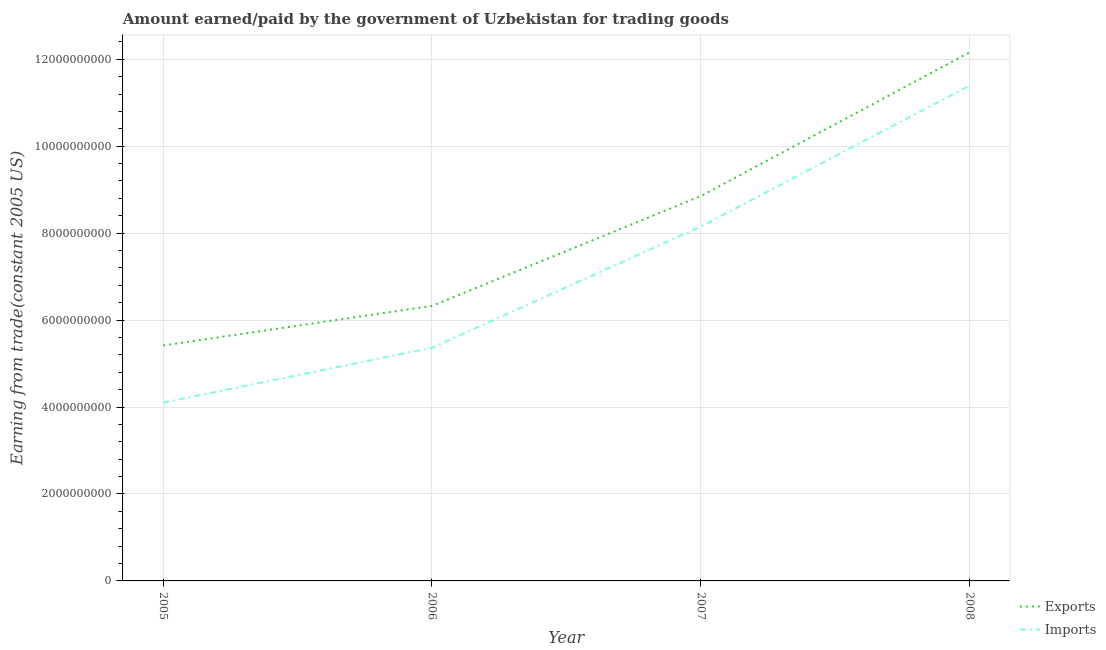Is the number of lines equal to the number of legend labels?
Offer a terse response. Yes. What is the amount paid for imports in 2005?
Offer a very short reply. 4.10e+09. Across all years, what is the maximum amount earned from exports?
Your response must be concise. 1.22e+1. Across all years, what is the minimum amount earned from exports?
Provide a short and direct response. 5.42e+09. What is the total amount earned from exports in the graph?
Give a very brief answer. 3.28e+1. What is the difference between the amount paid for imports in 2005 and that in 2006?
Your response must be concise. -1.26e+09. What is the difference between the amount earned from exports in 2006 and the amount paid for imports in 2005?
Offer a very short reply. 2.23e+09. What is the average amount earned from exports per year?
Ensure brevity in your answer.  8.19e+09. In the year 2008, what is the difference between the amount earned from exports and amount paid for imports?
Your answer should be very brief. 7.65e+08. What is the ratio of the amount earned from exports in 2005 to that in 2008?
Give a very brief answer. 0.45. Is the amount paid for imports in 2006 less than that in 2007?
Offer a very short reply. Yes. Is the difference between the amount paid for imports in 2006 and 2007 greater than the difference between the amount earned from exports in 2006 and 2007?
Your answer should be very brief. No. What is the difference between the highest and the second highest amount paid for imports?
Make the answer very short. 3.24e+09. What is the difference between the highest and the lowest amount paid for imports?
Provide a short and direct response. 7.29e+09. Is the sum of the amount earned from exports in 2007 and 2008 greater than the maximum amount paid for imports across all years?
Keep it short and to the point. Yes. Does the amount earned from exports monotonically increase over the years?
Keep it short and to the point. Yes. Is the amount paid for imports strictly greater than the amount earned from exports over the years?
Make the answer very short. No. How many years are there in the graph?
Provide a succinct answer. 4. Are the values on the major ticks of Y-axis written in scientific E-notation?
Provide a short and direct response. No. Does the graph contain any zero values?
Provide a short and direct response. No. Does the graph contain grids?
Your answer should be compact. Yes. How are the legend labels stacked?
Ensure brevity in your answer.  Vertical. What is the title of the graph?
Your answer should be very brief. Amount earned/paid by the government of Uzbekistan for trading goods. Does "Working capital" appear as one of the legend labels in the graph?
Keep it short and to the point. No. What is the label or title of the X-axis?
Make the answer very short. Year. What is the label or title of the Y-axis?
Make the answer very short. Earning from trade(constant 2005 US). What is the Earning from trade(constant 2005 US) in Exports in 2005?
Offer a terse response. 5.42e+09. What is the Earning from trade(constant 2005 US) in Imports in 2005?
Provide a short and direct response. 4.10e+09. What is the Earning from trade(constant 2005 US) of Exports in 2006?
Your answer should be very brief. 6.33e+09. What is the Earning from trade(constant 2005 US) of Imports in 2006?
Keep it short and to the point. 5.36e+09. What is the Earning from trade(constant 2005 US) of Exports in 2007?
Offer a terse response. 8.85e+09. What is the Earning from trade(constant 2005 US) in Imports in 2007?
Keep it short and to the point. 8.15e+09. What is the Earning from trade(constant 2005 US) in Exports in 2008?
Make the answer very short. 1.22e+1. What is the Earning from trade(constant 2005 US) of Imports in 2008?
Offer a terse response. 1.14e+1. Across all years, what is the maximum Earning from trade(constant 2005 US) of Exports?
Offer a terse response. 1.22e+1. Across all years, what is the maximum Earning from trade(constant 2005 US) in Imports?
Your answer should be very brief. 1.14e+1. Across all years, what is the minimum Earning from trade(constant 2005 US) of Exports?
Give a very brief answer. 5.42e+09. Across all years, what is the minimum Earning from trade(constant 2005 US) in Imports?
Offer a terse response. 4.10e+09. What is the total Earning from trade(constant 2005 US) of Exports in the graph?
Provide a succinct answer. 3.28e+1. What is the total Earning from trade(constant 2005 US) in Imports in the graph?
Your answer should be compact. 2.90e+1. What is the difference between the Earning from trade(constant 2005 US) of Exports in 2005 and that in 2006?
Provide a short and direct response. -9.10e+08. What is the difference between the Earning from trade(constant 2005 US) of Imports in 2005 and that in 2006?
Ensure brevity in your answer.  -1.26e+09. What is the difference between the Earning from trade(constant 2005 US) in Exports in 2005 and that in 2007?
Provide a short and direct response. -3.44e+09. What is the difference between the Earning from trade(constant 2005 US) in Imports in 2005 and that in 2007?
Your response must be concise. -4.05e+09. What is the difference between the Earning from trade(constant 2005 US) in Exports in 2005 and that in 2008?
Make the answer very short. -6.74e+09. What is the difference between the Earning from trade(constant 2005 US) in Imports in 2005 and that in 2008?
Your response must be concise. -7.29e+09. What is the difference between the Earning from trade(constant 2005 US) of Exports in 2006 and that in 2007?
Give a very brief answer. -2.52e+09. What is the difference between the Earning from trade(constant 2005 US) in Imports in 2006 and that in 2007?
Ensure brevity in your answer.  -2.79e+09. What is the difference between the Earning from trade(constant 2005 US) of Exports in 2006 and that in 2008?
Ensure brevity in your answer.  -5.83e+09. What is the difference between the Earning from trade(constant 2005 US) in Imports in 2006 and that in 2008?
Your response must be concise. -6.03e+09. What is the difference between the Earning from trade(constant 2005 US) of Exports in 2007 and that in 2008?
Keep it short and to the point. -3.31e+09. What is the difference between the Earning from trade(constant 2005 US) in Imports in 2007 and that in 2008?
Your answer should be compact. -3.24e+09. What is the difference between the Earning from trade(constant 2005 US) in Exports in 2005 and the Earning from trade(constant 2005 US) in Imports in 2006?
Provide a succinct answer. 5.25e+07. What is the difference between the Earning from trade(constant 2005 US) of Exports in 2005 and the Earning from trade(constant 2005 US) of Imports in 2007?
Offer a very short reply. -2.73e+09. What is the difference between the Earning from trade(constant 2005 US) of Exports in 2005 and the Earning from trade(constant 2005 US) of Imports in 2008?
Offer a terse response. -5.98e+09. What is the difference between the Earning from trade(constant 2005 US) of Exports in 2006 and the Earning from trade(constant 2005 US) of Imports in 2007?
Your response must be concise. -1.82e+09. What is the difference between the Earning from trade(constant 2005 US) in Exports in 2006 and the Earning from trade(constant 2005 US) in Imports in 2008?
Make the answer very short. -5.07e+09. What is the difference between the Earning from trade(constant 2005 US) in Exports in 2007 and the Earning from trade(constant 2005 US) in Imports in 2008?
Your answer should be very brief. -2.54e+09. What is the average Earning from trade(constant 2005 US) in Exports per year?
Provide a short and direct response. 8.19e+09. What is the average Earning from trade(constant 2005 US) in Imports per year?
Offer a very short reply. 7.25e+09. In the year 2005, what is the difference between the Earning from trade(constant 2005 US) of Exports and Earning from trade(constant 2005 US) of Imports?
Make the answer very short. 1.32e+09. In the year 2006, what is the difference between the Earning from trade(constant 2005 US) in Exports and Earning from trade(constant 2005 US) in Imports?
Ensure brevity in your answer.  9.62e+08. In the year 2007, what is the difference between the Earning from trade(constant 2005 US) in Exports and Earning from trade(constant 2005 US) in Imports?
Your answer should be compact. 7.01e+08. In the year 2008, what is the difference between the Earning from trade(constant 2005 US) in Exports and Earning from trade(constant 2005 US) in Imports?
Your answer should be compact. 7.65e+08. What is the ratio of the Earning from trade(constant 2005 US) in Exports in 2005 to that in 2006?
Keep it short and to the point. 0.86. What is the ratio of the Earning from trade(constant 2005 US) in Imports in 2005 to that in 2006?
Offer a very short reply. 0.76. What is the ratio of the Earning from trade(constant 2005 US) of Exports in 2005 to that in 2007?
Ensure brevity in your answer.  0.61. What is the ratio of the Earning from trade(constant 2005 US) in Imports in 2005 to that in 2007?
Ensure brevity in your answer.  0.5. What is the ratio of the Earning from trade(constant 2005 US) of Exports in 2005 to that in 2008?
Make the answer very short. 0.45. What is the ratio of the Earning from trade(constant 2005 US) in Imports in 2005 to that in 2008?
Make the answer very short. 0.36. What is the ratio of the Earning from trade(constant 2005 US) in Exports in 2006 to that in 2007?
Make the answer very short. 0.71. What is the ratio of the Earning from trade(constant 2005 US) of Imports in 2006 to that in 2007?
Your response must be concise. 0.66. What is the ratio of the Earning from trade(constant 2005 US) of Exports in 2006 to that in 2008?
Provide a succinct answer. 0.52. What is the ratio of the Earning from trade(constant 2005 US) of Imports in 2006 to that in 2008?
Make the answer very short. 0.47. What is the ratio of the Earning from trade(constant 2005 US) in Exports in 2007 to that in 2008?
Keep it short and to the point. 0.73. What is the ratio of the Earning from trade(constant 2005 US) in Imports in 2007 to that in 2008?
Give a very brief answer. 0.72. What is the difference between the highest and the second highest Earning from trade(constant 2005 US) of Exports?
Provide a succinct answer. 3.31e+09. What is the difference between the highest and the second highest Earning from trade(constant 2005 US) of Imports?
Give a very brief answer. 3.24e+09. What is the difference between the highest and the lowest Earning from trade(constant 2005 US) in Exports?
Provide a succinct answer. 6.74e+09. What is the difference between the highest and the lowest Earning from trade(constant 2005 US) in Imports?
Keep it short and to the point. 7.29e+09. 